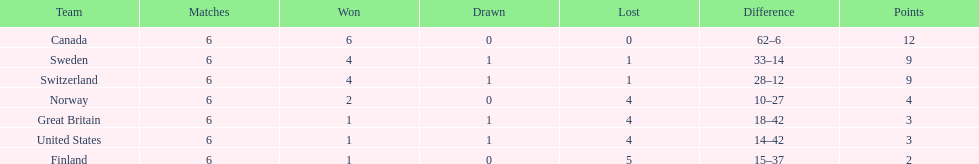What team placed next after sweden? Switzerland. Parse the table in full. {'header': ['Team', 'Matches', 'Won', 'Drawn', 'Lost', 'Difference', 'Points'], 'rows': [['Canada', '6', '6', '0', '0', '62–6', '12'], ['Sweden', '6', '4', '1', '1', '33–14', '9'], ['Switzerland', '6', '4', '1', '1', '28–12', '9'], ['Norway', '6', '2', '0', '4', '10–27', '4'], ['Great Britain', '6', '1', '1', '4', '18–42', '3'], ['United States', '6', '1', '1', '4', '14–42', '3'], ['Finland', '6', '1', '0', '5', '15–37', '2']]} 